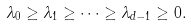Convert formula to latex. <formula><loc_0><loc_0><loc_500><loc_500>\lambda _ { 0 } \geq \lambda _ { 1 } \geq \dots \geq \lambda _ { d - 1 } \geq 0 .</formula> 